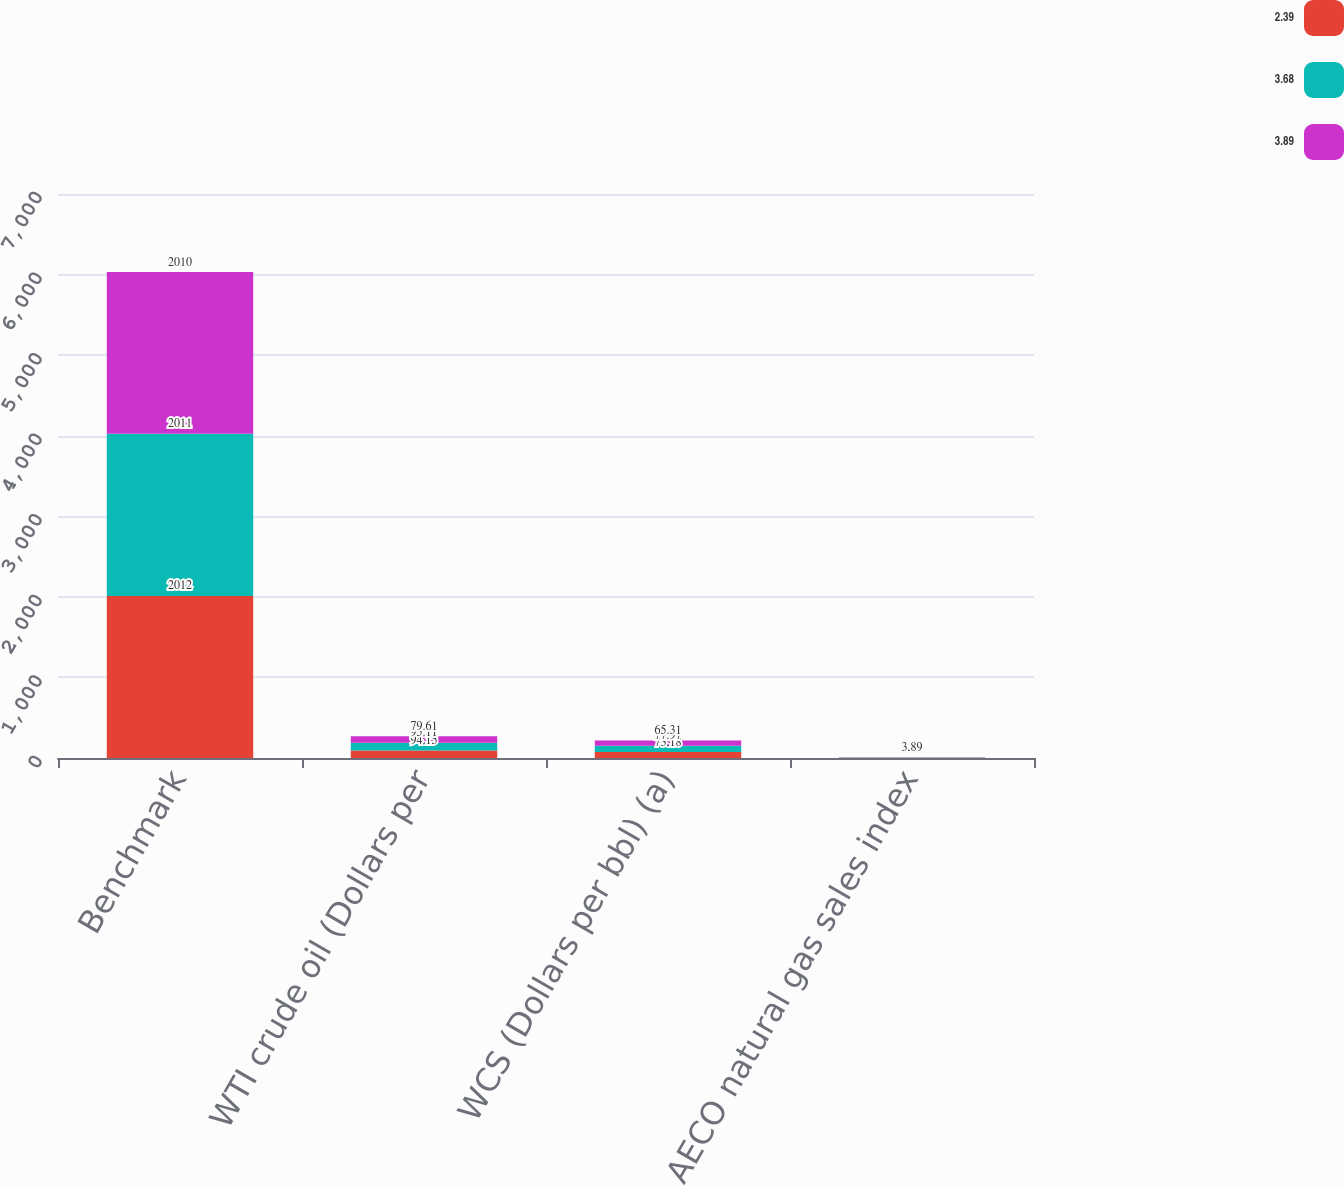<chart> <loc_0><loc_0><loc_500><loc_500><stacked_bar_chart><ecel><fcel>Benchmark<fcel>WTI crude oil (Dollars per<fcel>WCS (Dollars per bbl) (a)<fcel>AECO natural gas sales index<nl><fcel>2.39<fcel>2012<fcel>94.15<fcel>73.18<fcel>2.39<nl><fcel>3.68<fcel>2011<fcel>95.11<fcel>77.97<fcel>3.68<nl><fcel>3.89<fcel>2010<fcel>79.61<fcel>65.31<fcel>3.89<nl></chart> 